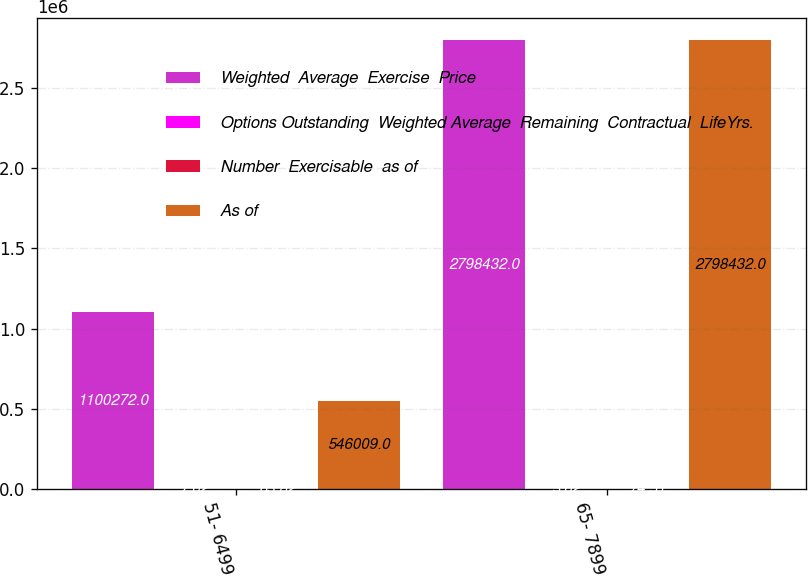<chart> <loc_0><loc_0><loc_500><loc_500><stacked_bar_chart><ecel><fcel>51- 6499<fcel>65- 7899<nl><fcel>Weighted  Average  Exercise  Price<fcel>1.10027e+06<fcel>2.79843e+06<nl><fcel>Options Outstanding  Weighted Average  Remaining  Contractual  LifeYrs.<fcel>7.62<fcel>3.62<nl><fcel>Number  Exercisable  as of<fcel>63.82<fcel>74.51<nl><fcel>As of<fcel>546009<fcel>2.79843e+06<nl></chart> 